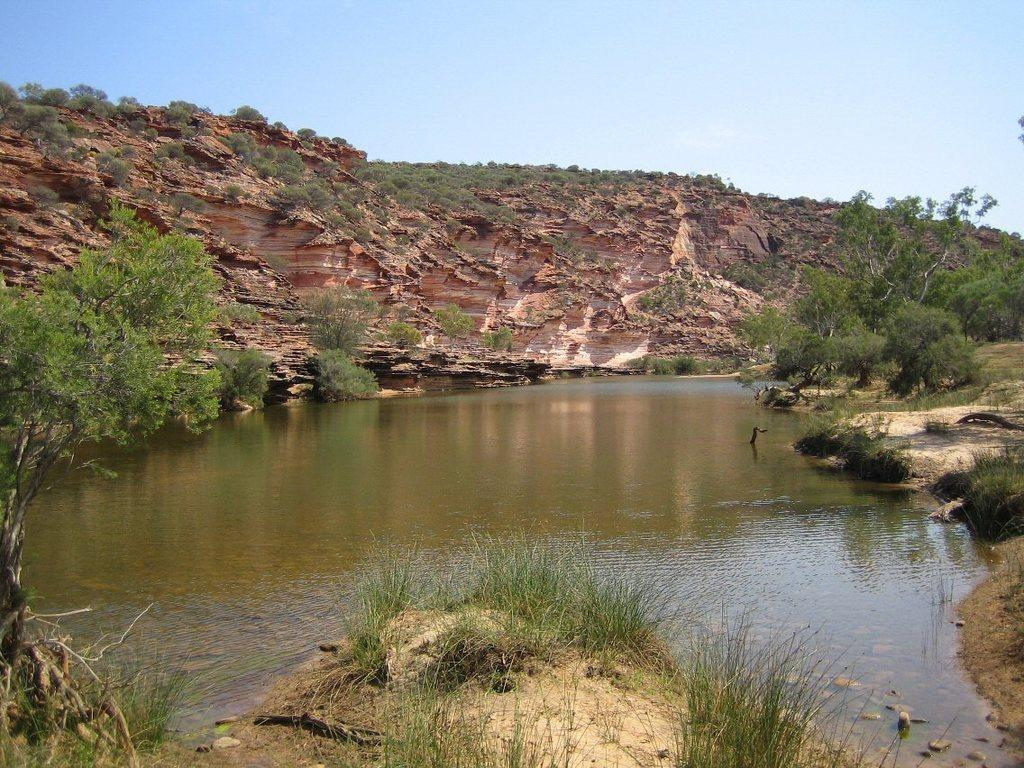What type of natural environment can be seen in the image? The image features water, grass, plants, trees, hills, and the sky, indicating a natural environment. What is visible on the ground in the image? The ground is visible in the image, and it includes grass and plants. What type of terrain is present in the image? The image features hills, suggesting a hilly terrain. What is the weather like in the image? The presence of trees, grass, and plants suggests that the weather is suitable for their growth, but the specific weather conditions cannot be determined from the image. How many tents can be seen in the image? There are no tents present in the image. What type of iron object is visible in the image? There is no iron object visible in the image. 